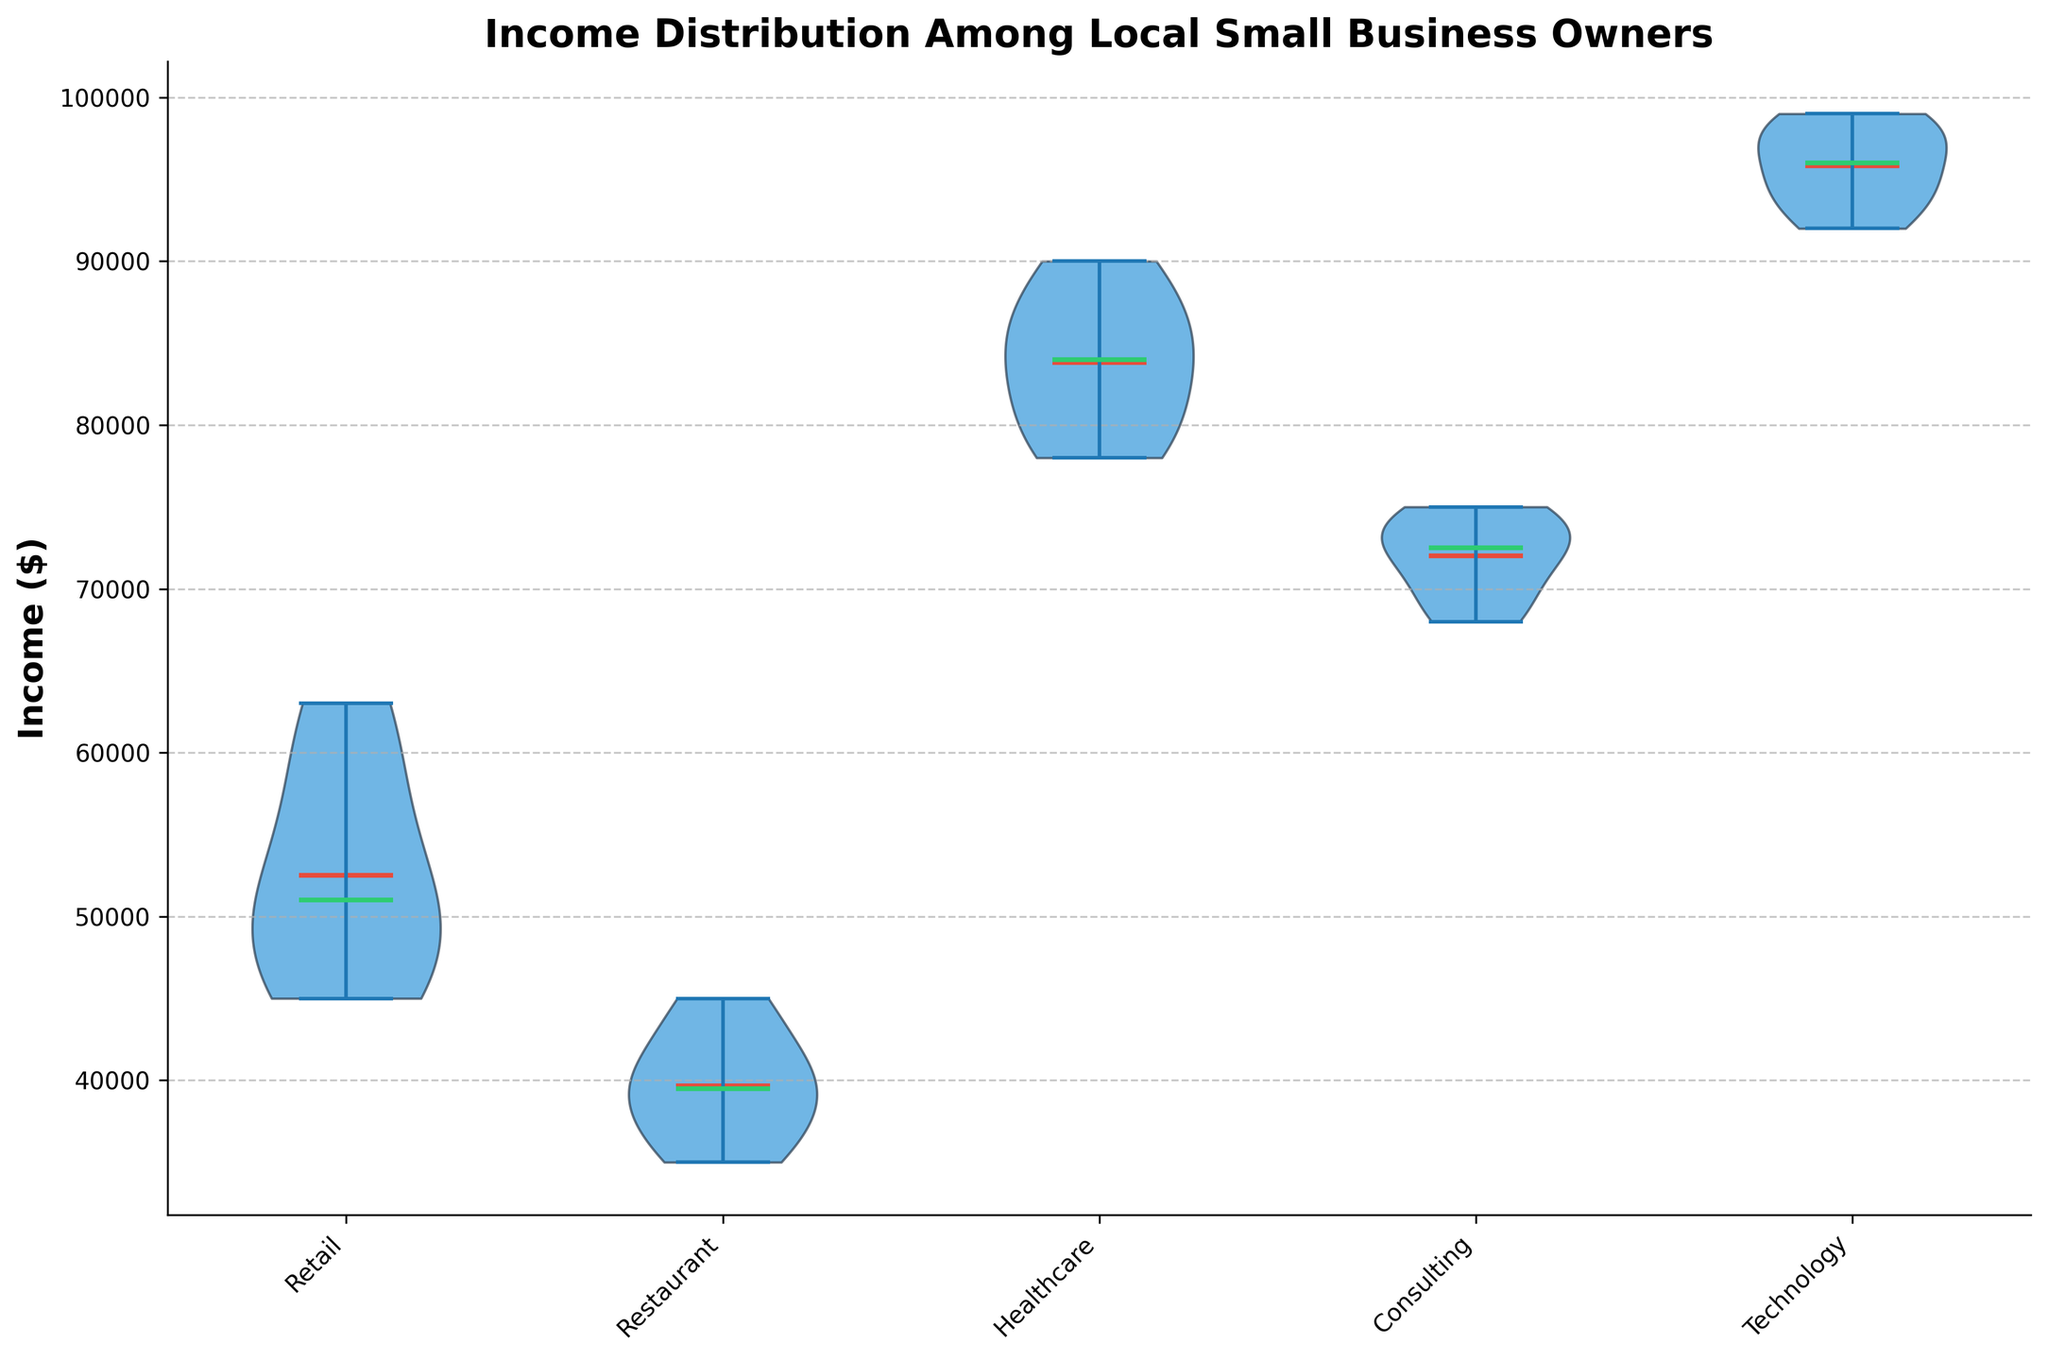what is the title of the figure? The title of the figure is displayed at the top of the plot. By reading the text, we can identify what the chart is about.
Answer: Income Distribution Among Local Small Business Owners What is the y-axis label? The y-axis label is written along the vertical axis of the plot.
Answer: Income ($) How many industries are represented in the plot? By counting the number of unique labels along the x-axis of the plot, we can determine the number of different industries represented.
Answer: 5 Which industry has the highest mean income? The mean income is indicated by the red point inside each violin shape. The highest mean income can be identified by comparing these points across the different industries.
Answer: Technology Which industry has the lowest median income? The median income is indicated by the green line inside each violin shape. By comparing the position of these lines across the industries, we can determine which industry has the lowest median income.
Answer: Restaurant Compare the range of incomes within the Healthcare and Retail industries. Which is broader? The range of income is represented by the size of the violin shape. By visually comparing the width of the violins for Healthcare and Retail, we can determine which one has a broader range.
Answer: Retail What is the median income in the Consulting industry? The median income is represented by the green line in the violin for the Consulting industry. We can read the value directly from this line.
Answer: 73000 Which industry has the widest spread of incomes? The spread of incomes is represented by both the height and width of the violin shapes. The industry with the widest and tallest violin indicates the widest spread. This can be determined by comparing the shapes visually.
Answer: Retail How do the means of the incomes compare between Healthcare and Consulting industries? By comparing the red points representing the means in the Healthcare and Consulting violins, we can see how they differ.
Answer: Healthcare has a higher mean What is the income range for the Technology industry? The range is represented by the top and bottom of the violin shape for the Technology industry. By reading these values, we can determine the income range.
Answer: 92000 to 99000 